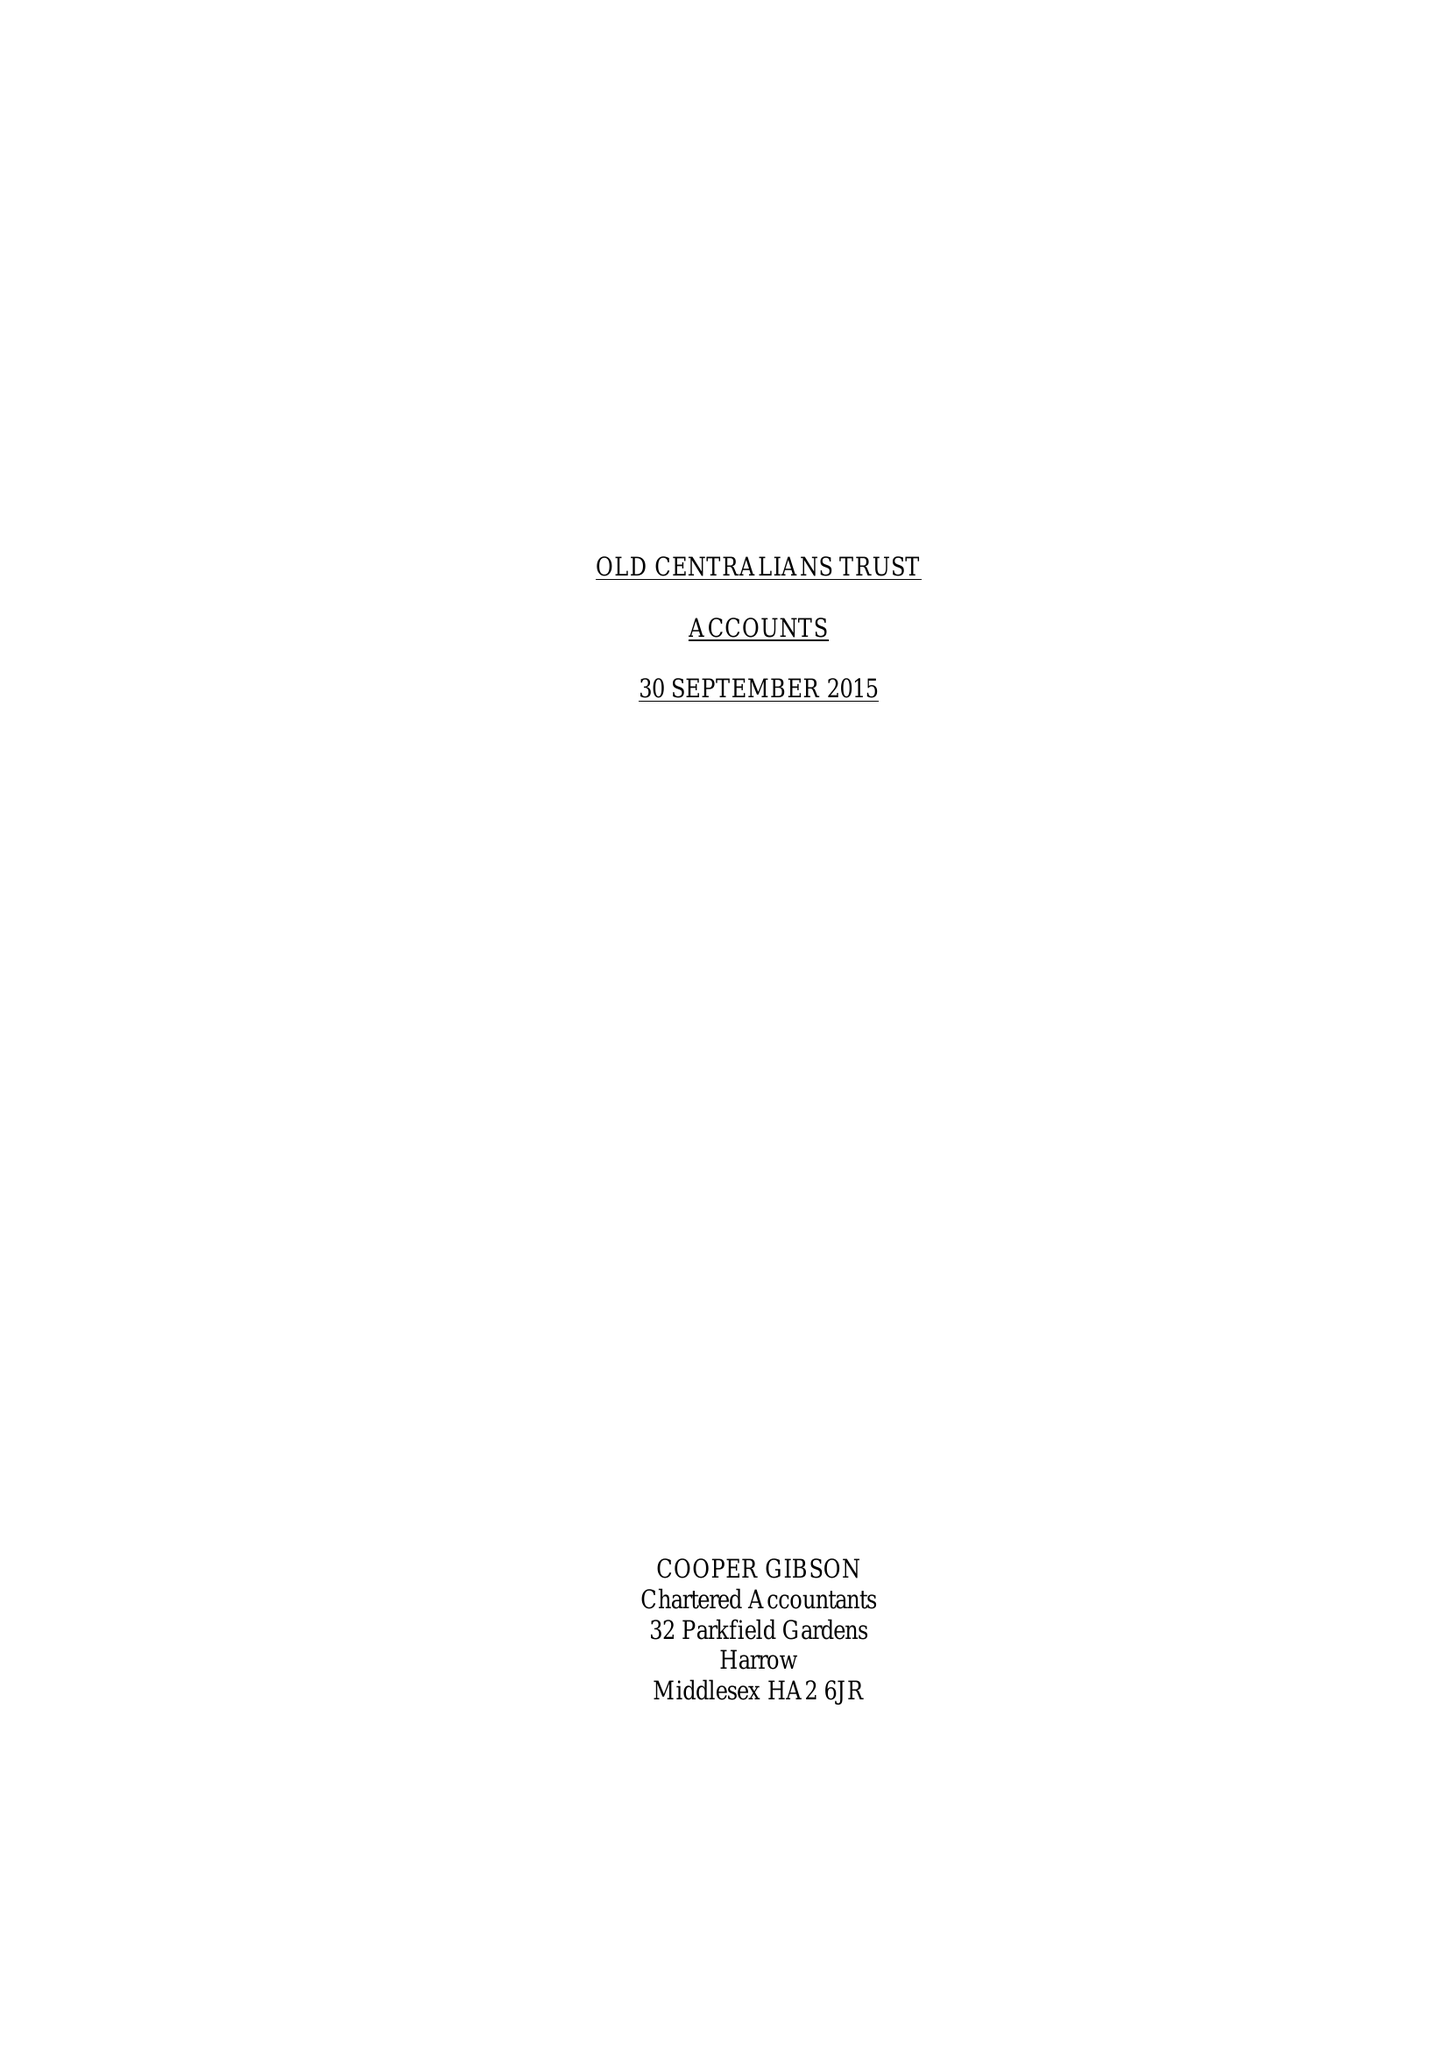What is the value for the charity_name?
Answer the question using a single word or phrase. Old Centralians Trust 